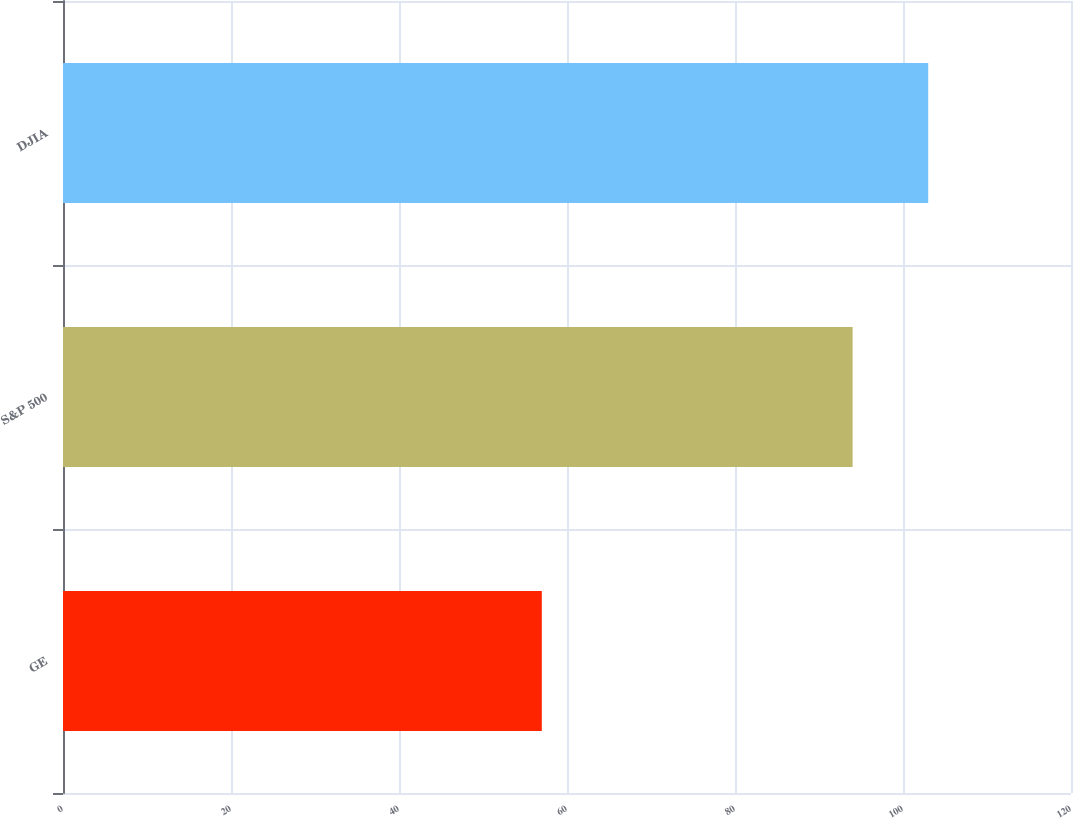<chart> <loc_0><loc_0><loc_500><loc_500><bar_chart><fcel>GE<fcel>S&P 500<fcel>DJIA<nl><fcel>57<fcel>94<fcel>103<nl></chart> 